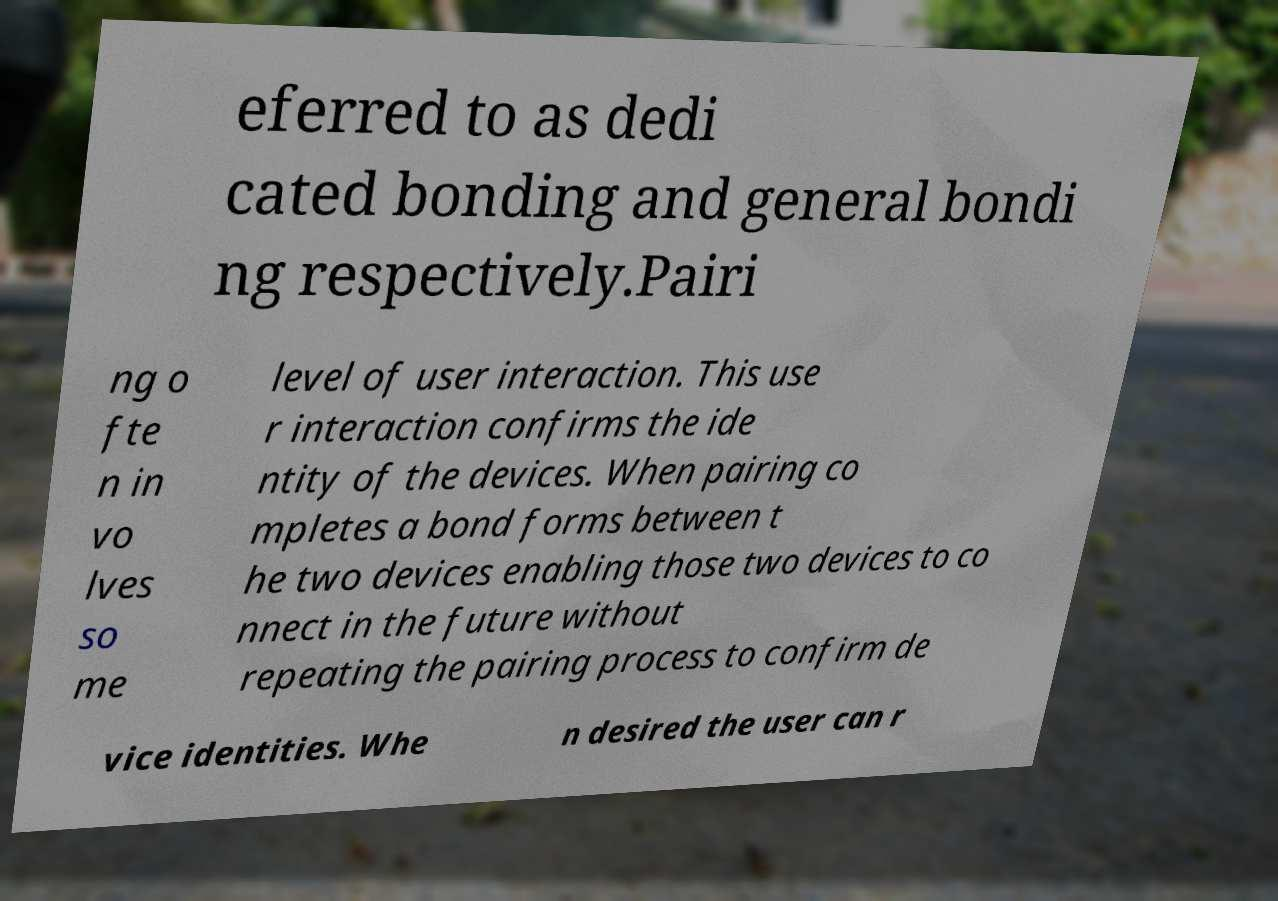Could you extract and type out the text from this image? eferred to as dedi cated bonding and general bondi ng respectively.Pairi ng o fte n in vo lves so me level of user interaction. This use r interaction confirms the ide ntity of the devices. When pairing co mpletes a bond forms between t he two devices enabling those two devices to co nnect in the future without repeating the pairing process to confirm de vice identities. Whe n desired the user can r 